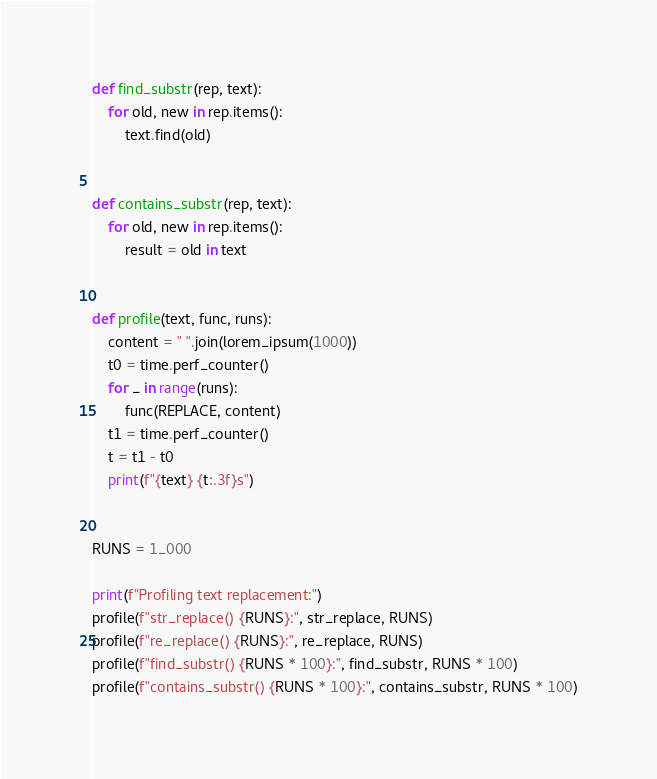Convert code to text. <code><loc_0><loc_0><loc_500><loc_500><_Python_>

def find_substr(rep, text):
    for old, new in rep.items():
        text.find(old)


def contains_substr(rep, text):
    for old, new in rep.items():
        result = old in text


def profile(text, func, runs):
    content = " ".join(lorem_ipsum(1000))
    t0 = time.perf_counter()
    for _ in range(runs):
        func(REPLACE, content)
    t1 = time.perf_counter()
    t = t1 - t0
    print(f"{text} {t:.3f}s")


RUNS = 1_000

print(f"Profiling text replacement:")
profile(f"str_replace() {RUNS}:", str_replace, RUNS)
profile(f"re_replace() {RUNS}:", re_replace, RUNS)
profile(f"find_substr() {RUNS * 100}:", find_substr, RUNS * 100)
profile(f"contains_substr() {RUNS * 100}:", contains_substr, RUNS * 100)
</code> 